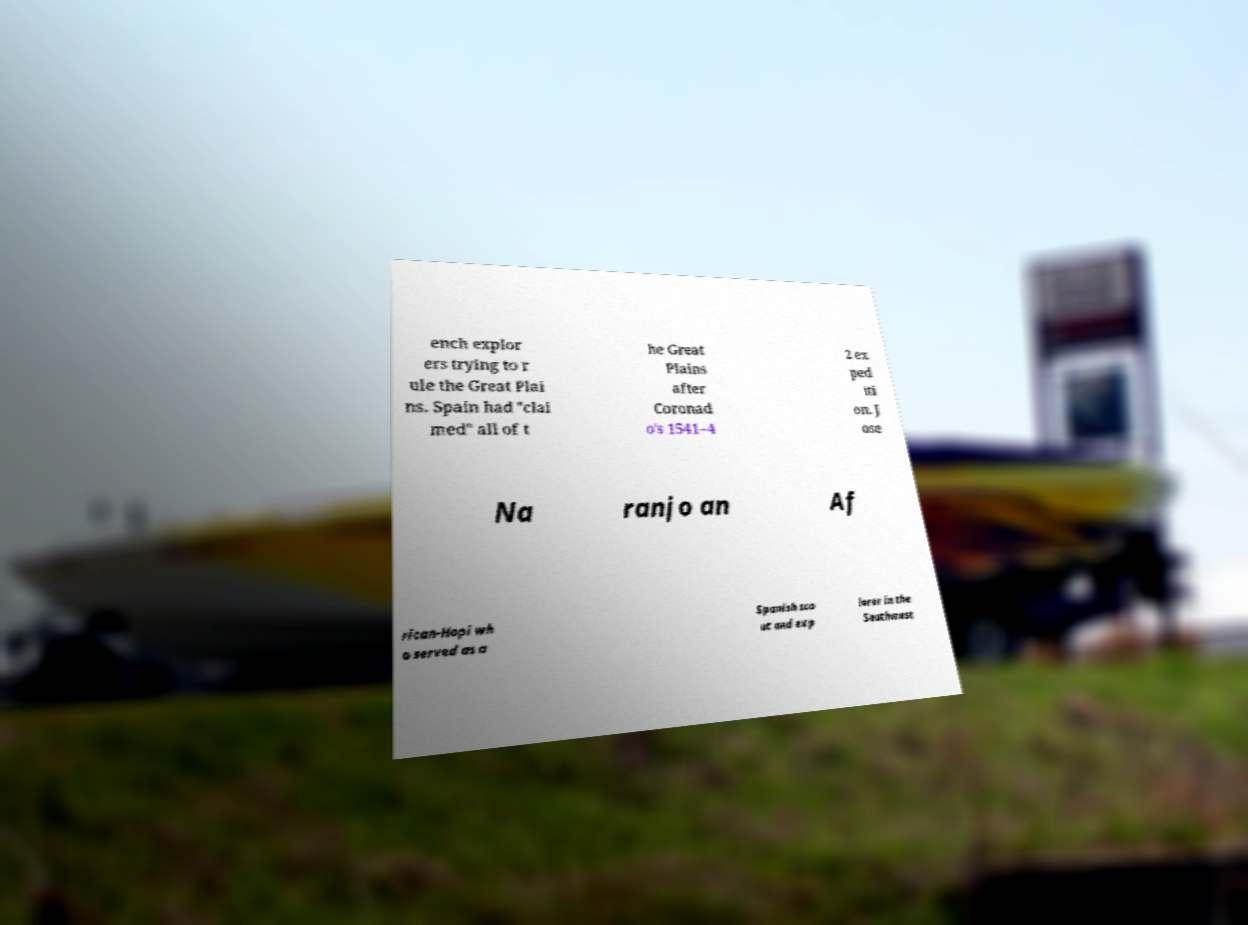Please identify and transcribe the text found in this image. ench explor ers trying to r ule the Great Plai ns. Spain had "clai med" all of t he Great Plains after Coronad o's 1541–4 2 ex ped iti on. J ose Na ranjo an Af rican-Hopi wh o served as a Spanish sco ut and exp lorer in the Southwest 